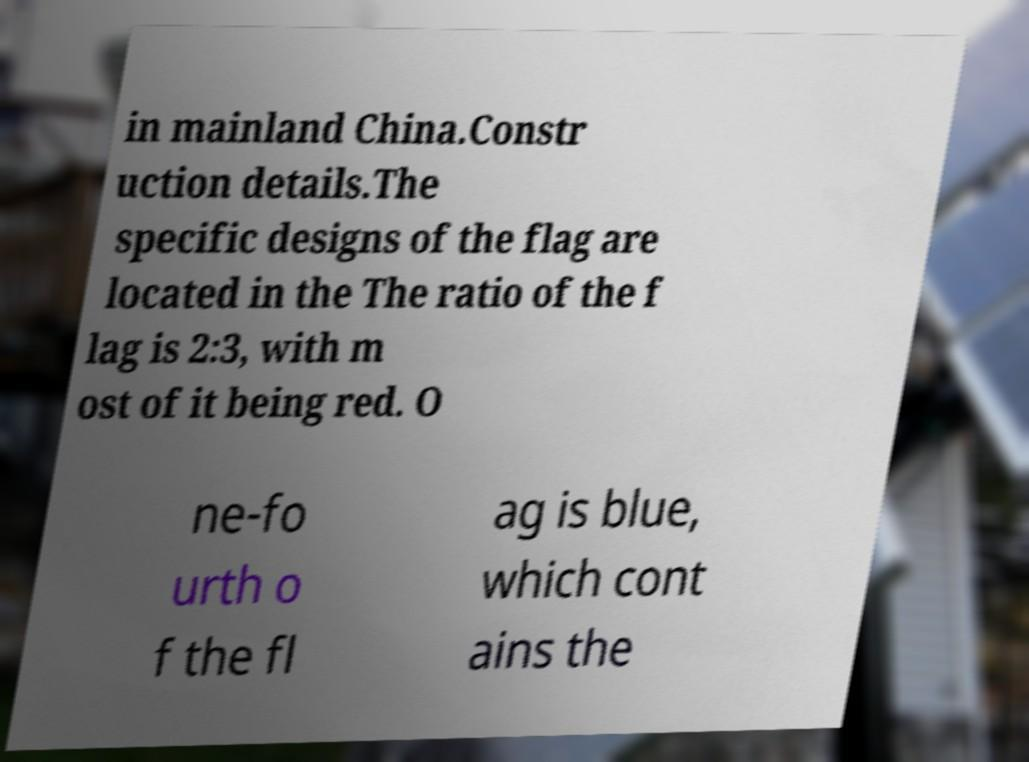Can you read and provide the text displayed in the image?This photo seems to have some interesting text. Can you extract and type it out for me? in mainland China.Constr uction details.The specific designs of the flag are located in the The ratio of the f lag is 2:3, with m ost of it being red. O ne-fo urth o f the fl ag is blue, which cont ains the 